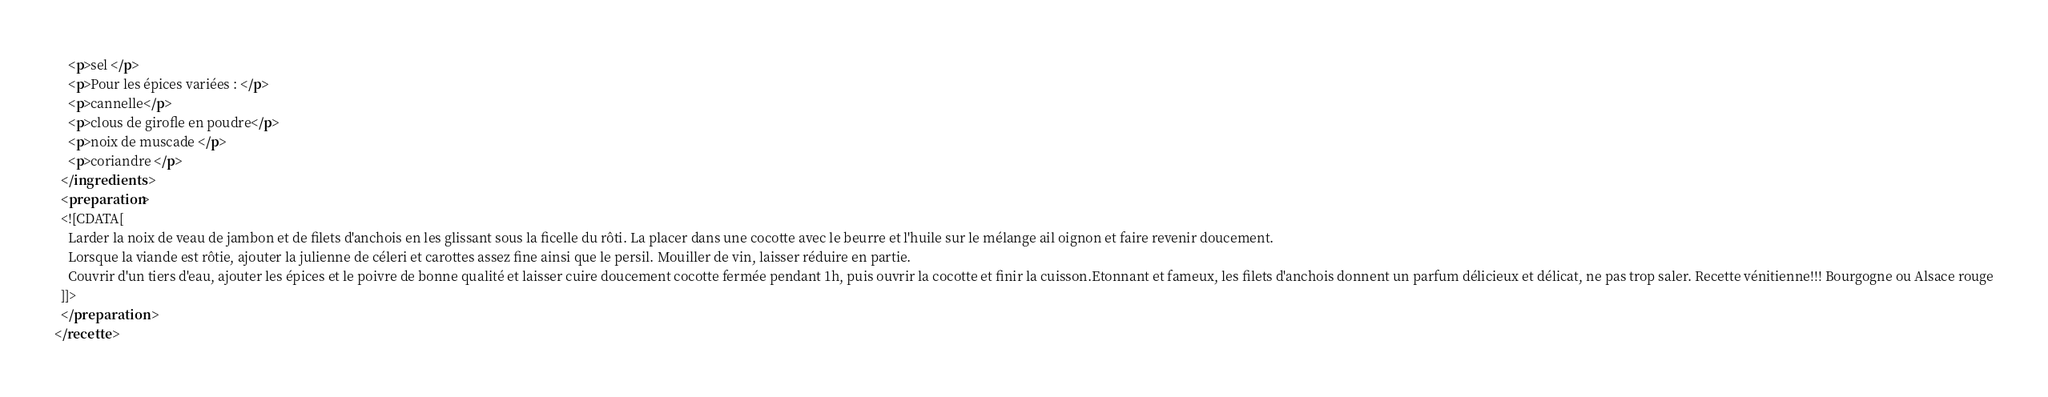<code> <loc_0><loc_0><loc_500><loc_500><_XML_>    <p>sel </p>
    <p>Pour les épices variées : </p>
    <p>cannelle</p>
    <p>clous de girofle en poudre</p>
    <p>noix de muscade </p>
    <p>coriandre </p>
  </ingredients>
  <preparation>
  <![CDATA[
    Larder la noix de veau de jambon et de filets d'anchois en les glissant sous la ficelle du rôti. La placer dans une cocotte avec le beurre et l'huile sur le mélange ail oignon et faire revenir doucement.
    Lorsque la viande est rôtie, ajouter la julienne de céleri et carottes assez fine ainsi que le persil. Mouiller de vin, laisser réduire en partie.
    Couvrir d'un tiers d'eau, ajouter les épices et le poivre de bonne qualité et laisser cuire doucement cocotte fermée pendant 1h, puis ouvrir la cocotte et finir la cuisson.Etonnant et fameux, les filets d'anchois donnent un parfum délicieux et délicat, ne pas trop saler. Recette vénitienne!!! Bourgogne ou Alsace rouge
  ]]>
  </preparation>
</recette>
</code> 